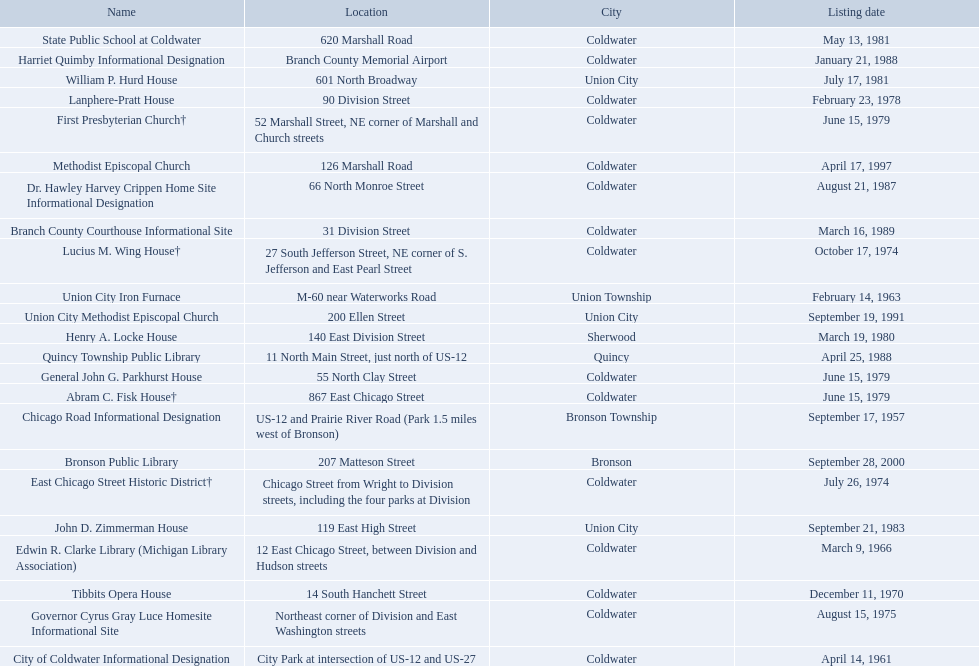What are all of the locations considered historical sites in branch county, michigan? Branch County Courthouse Informational Site, Bronson Public Library, Chicago Road Informational Designation, City of Coldwater Informational Designation, Edwin R. Clarke Library (Michigan Library Association), Dr. Hawley Harvey Crippen Home Site Informational Designation, East Chicago Street Historic District†, First Presbyterian Church†, Abram C. Fisk House†, William P. Hurd House, Lanphere-Pratt House, Henry A. Locke House, Governor Cyrus Gray Luce Homesite Informational Site, Methodist Episcopal Church, General John G. Parkhurst House, Harriet Quimby Informational Designation, Quincy Township Public Library, State Public School at Coldwater, Tibbits Opera House, Union City Iron Furnace, Union City Methodist Episcopal Church, Lucius M. Wing House†, John D. Zimmerman House. Of those sites, which one was the first to be listed as historical? Chicago Road Informational Designation. 